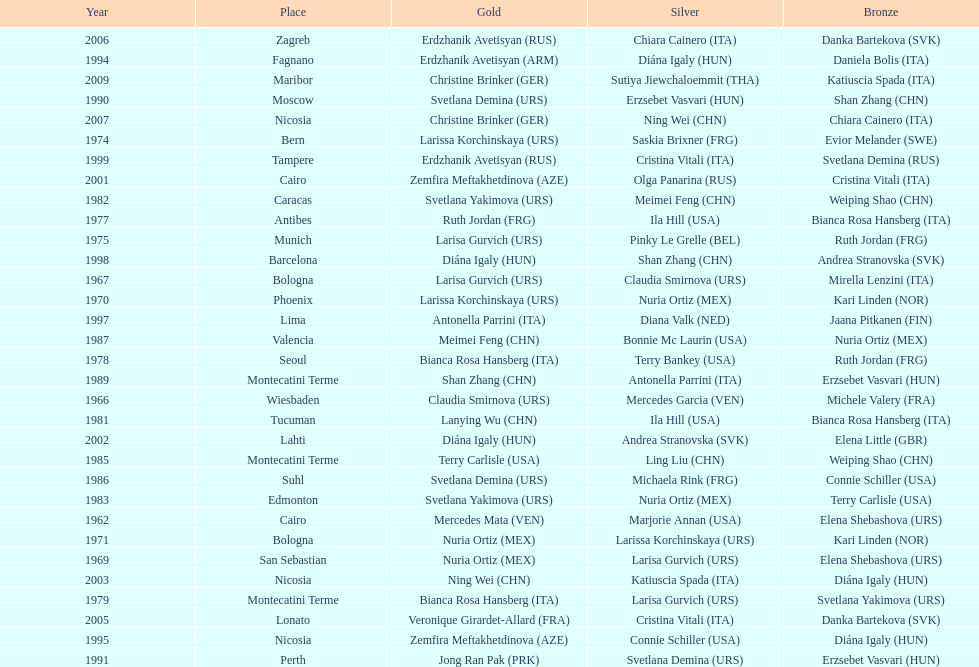How many gold did u.s.a win 1. 